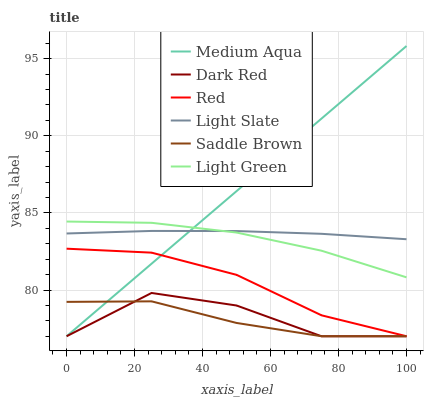Does Dark Red have the minimum area under the curve?
Answer yes or no. No. Does Dark Red have the maximum area under the curve?
Answer yes or no. No. Is Dark Red the smoothest?
Answer yes or no. No. Is Medium Aqua the roughest?
Answer yes or no. No. Does Light Green have the lowest value?
Answer yes or no. No. Does Dark Red have the highest value?
Answer yes or no. No. Is Dark Red less than Light Green?
Answer yes or no. Yes. Is Light Green greater than Dark Red?
Answer yes or no. Yes. Does Dark Red intersect Light Green?
Answer yes or no. No. 